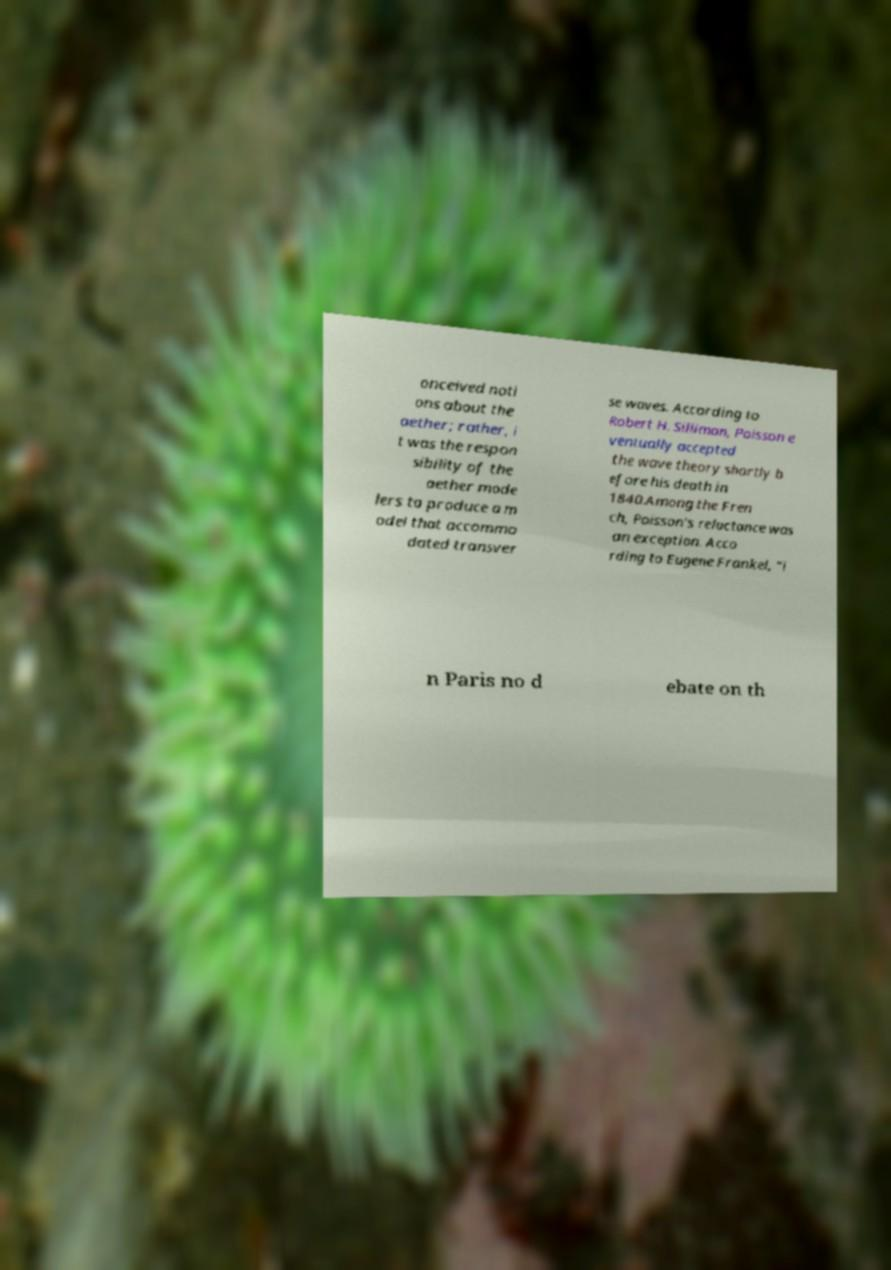What messages or text are displayed in this image? I need them in a readable, typed format. onceived noti ons about the aether; rather, i t was the respon sibility of the aether mode lers to produce a m odel that accommo dated transver se waves. According to Robert H. Silliman, Poisson e ventually accepted the wave theory shortly b efore his death in 1840.Among the Fren ch, Poisson's reluctance was an exception. Acco rding to Eugene Frankel, "i n Paris no d ebate on th 